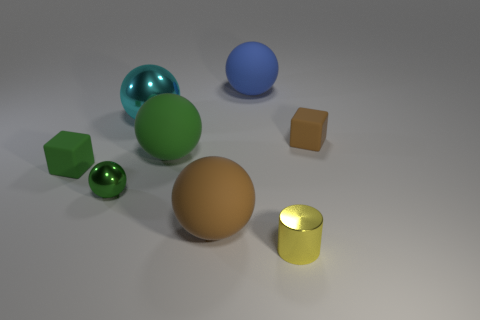Subtract all cyan blocks. How many green balls are left? 2 Subtract 2 balls. How many balls are left? 3 Subtract all brown balls. How many balls are left? 4 Subtract all big metal spheres. How many spheres are left? 4 Add 2 small brown matte objects. How many objects exist? 10 Subtract all yellow spheres. Subtract all yellow cubes. How many spheres are left? 5 Subtract all cylinders. How many objects are left? 7 Subtract 1 cyan balls. How many objects are left? 7 Subtract all tiny cyan metal cubes. Subtract all tiny rubber cubes. How many objects are left? 6 Add 5 small cylinders. How many small cylinders are left? 6 